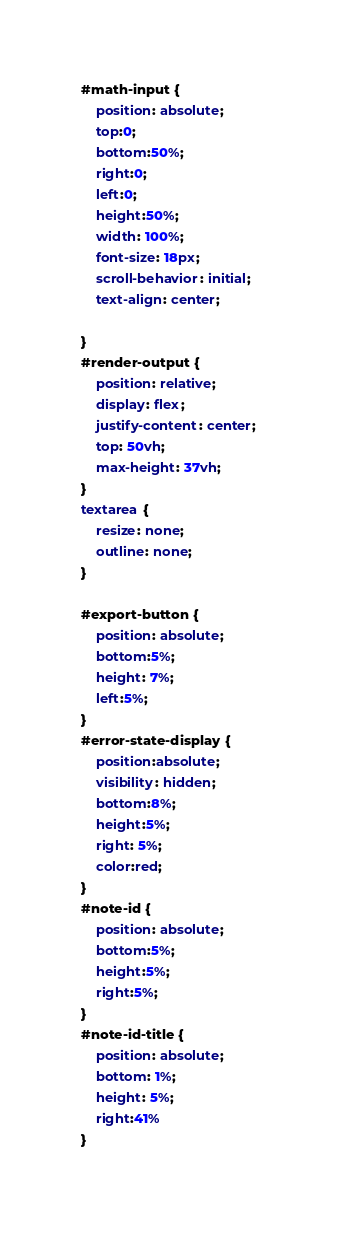Convert code to text. <code><loc_0><loc_0><loc_500><loc_500><_CSS_>#math-input {
    position: absolute;
    top:0;
    bottom:50%;
    right:0;
    left:0;
    height:50%;
    width: 100%;
    font-size: 18px;
    scroll-behavior: initial;
    text-align: center;
    
}
#render-output {
    position: relative;
    display: flex;
    justify-content: center;
    top: 50vh;
    max-height: 37vh;
}
textarea {
    resize: none;
    outline: none;
}

#export-button {
    position: absolute;
    bottom:5%;
    height: 7%;
    left:5%;
}
#error-state-display {
    position:absolute;
    visibility: hidden;
    bottom:8%;
    height:5%;
    right: 5%;
    color:red;
}
#note-id {
    position: absolute;
    bottom:5%;
    height:5%;
    right:5%;
}
#note-id-title {
    position: absolute;
    bottom: 1%;
    height: 5%;
    right:41%
}</code> 